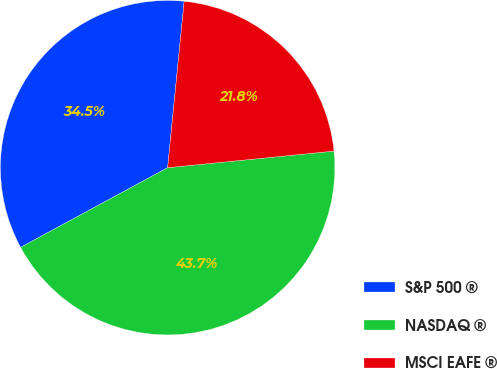<chart> <loc_0><loc_0><loc_500><loc_500><pie_chart><fcel>S&P 500 ®<fcel>NASDAQ ®<fcel>MSCI EAFE ®<nl><fcel>34.48%<fcel>43.68%<fcel>21.84%<nl></chart> 